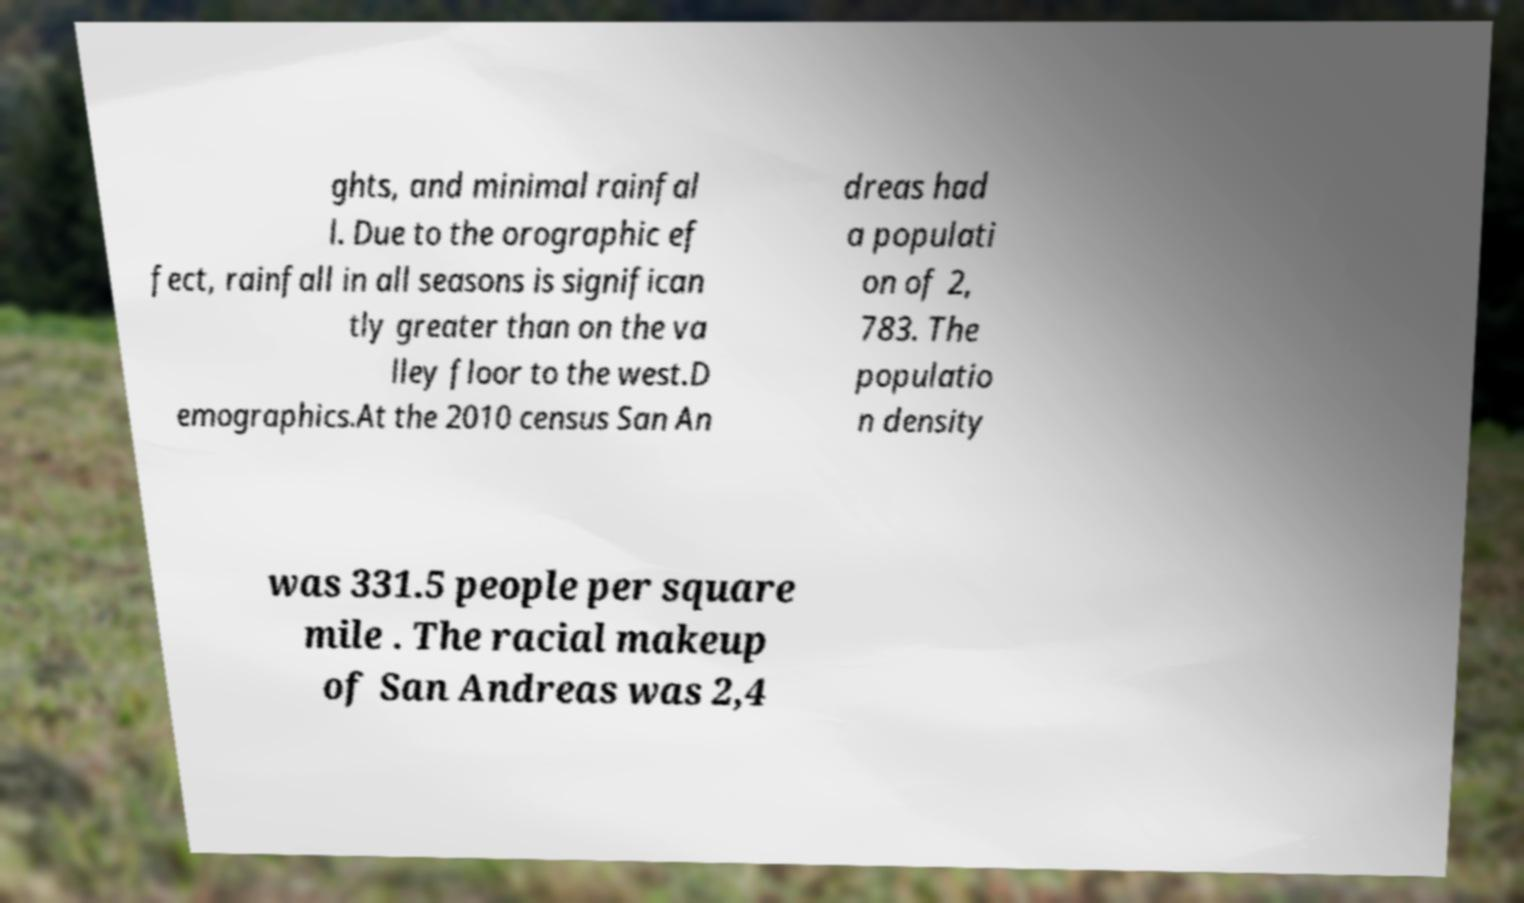I need the written content from this picture converted into text. Can you do that? ghts, and minimal rainfal l. Due to the orographic ef fect, rainfall in all seasons is significan tly greater than on the va lley floor to the west.D emographics.At the 2010 census San An dreas had a populati on of 2, 783. The populatio n density was 331.5 people per square mile . The racial makeup of San Andreas was 2,4 